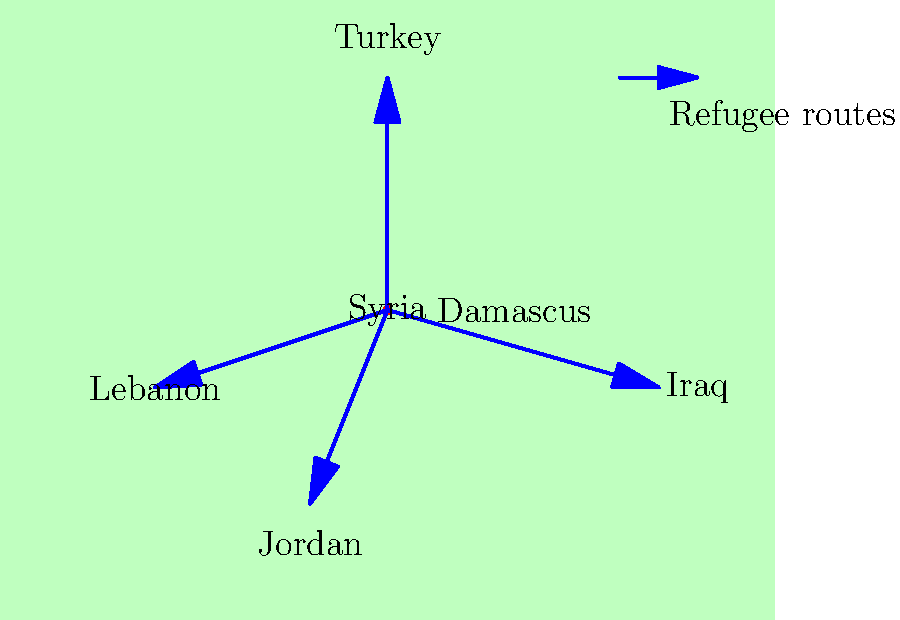Based on the map, which neighboring country appears to receive the most direct refugee flow from Syria's capital, Damascus? To answer this question, we need to analyze the map and follow these steps:

1. Identify Damascus: The capital city of Syria is marked with a red dot and labeled "Damascus" in the center of the country.

2. Observe the refugee routes: Blue arrows indicate the main refugee routes from Damascus to neighboring countries.

3. Analyze the directions:
   - One arrow points north towards Turkey
   - One arrow points west towards Lebanon
   - One arrow points south towards Jordan
   - One arrow points east towards Iraq

4. Compare the routes: 
   - The route to Turkey appears to be the longest and most direct.
   - The routes to Lebanon, Jordan, and Iraq are shorter and less prominent.

5. Conclusion: Based on the map, the arrow pointing north towards Turkey is the most prominent and direct, suggesting that Turkey likely receives the most direct refugee flow from Damascus.
Answer: Turkey 